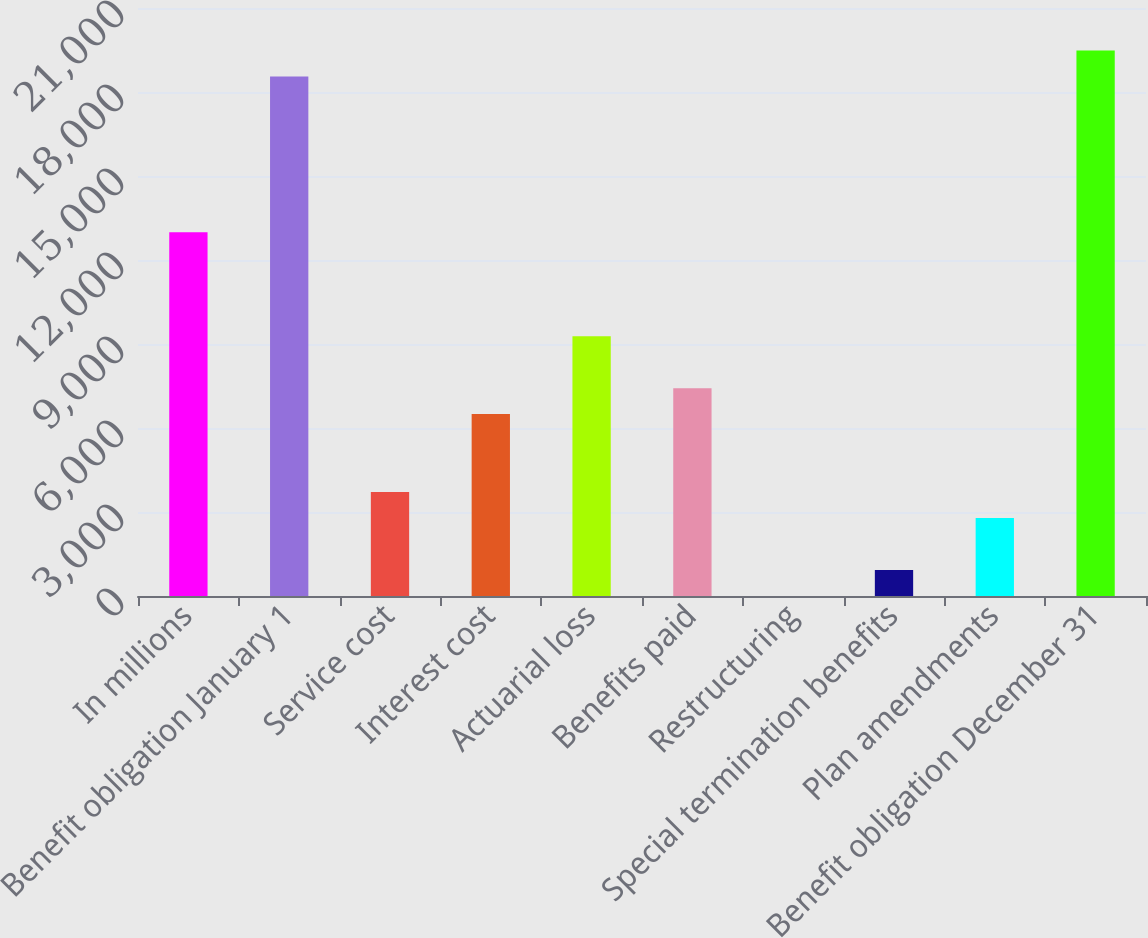Convert chart. <chart><loc_0><loc_0><loc_500><loc_500><bar_chart><fcel>In millions<fcel>Benefit obligation January 1<fcel>Service cost<fcel>Interest cost<fcel>Actuarial loss<fcel>Benefits paid<fcel>Restructuring<fcel>Special termination benefits<fcel>Plan amendments<fcel>Benefit obligation December 31<nl><fcel>12987.6<fcel>18552<fcel>3713.6<fcel>6495.8<fcel>9278<fcel>7423.2<fcel>4<fcel>931.4<fcel>2786.2<fcel>19479.4<nl></chart> 